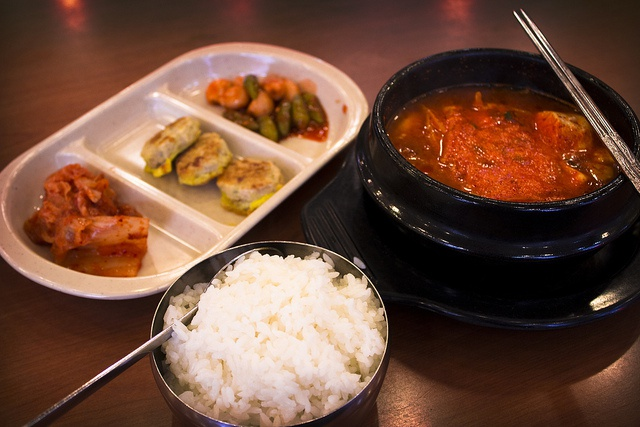Describe the objects in this image and their specific colors. I can see dining table in black, maroon, lightgray, and tan tones, bowl in black, brown, maroon, and red tones, bowl in black, lightgray, and tan tones, spoon in black, maroon, gray, and white tones, and spoon in black, lightgray, and tan tones in this image. 